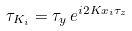Convert formula to latex. <formula><loc_0><loc_0><loc_500><loc_500>\tau _ { K _ { i } } = \tau _ { y } \, e ^ { i 2 K x _ { i } \tau _ { z } }</formula> 